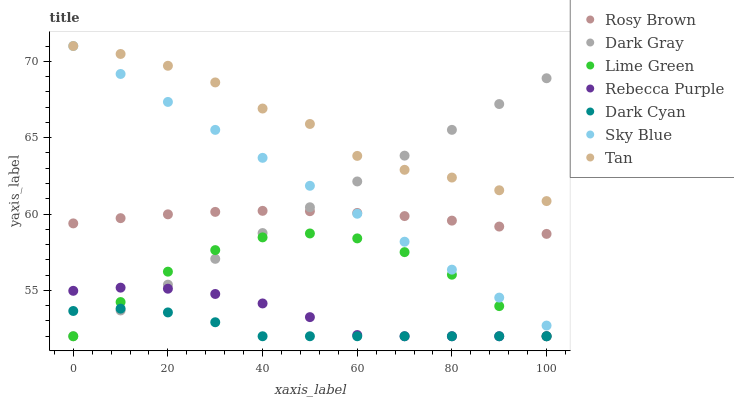Does Dark Cyan have the minimum area under the curve?
Answer yes or no. Yes. Does Tan have the maximum area under the curve?
Answer yes or no. Yes. Does Dark Gray have the minimum area under the curve?
Answer yes or no. No. Does Dark Gray have the maximum area under the curve?
Answer yes or no. No. Is Sky Blue the smoothest?
Answer yes or no. Yes. Is Tan the roughest?
Answer yes or no. Yes. Is Dark Gray the smoothest?
Answer yes or no. No. Is Dark Gray the roughest?
Answer yes or no. No. Does Dark Gray have the lowest value?
Answer yes or no. Yes. Does Sky Blue have the lowest value?
Answer yes or no. No. Does Tan have the highest value?
Answer yes or no. Yes. Does Dark Gray have the highest value?
Answer yes or no. No. Is Rebecca Purple less than Tan?
Answer yes or no. Yes. Is Rosy Brown greater than Rebecca Purple?
Answer yes or no. Yes. Does Rebecca Purple intersect Dark Gray?
Answer yes or no. Yes. Is Rebecca Purple less than Dark Gray?
Answer yes or no. No. Is Rebecca Purple greater than Dark Gray?
Answer yes or no. No. Does Rebecca Purple intersect Tan?
Answer yes or no. No. 